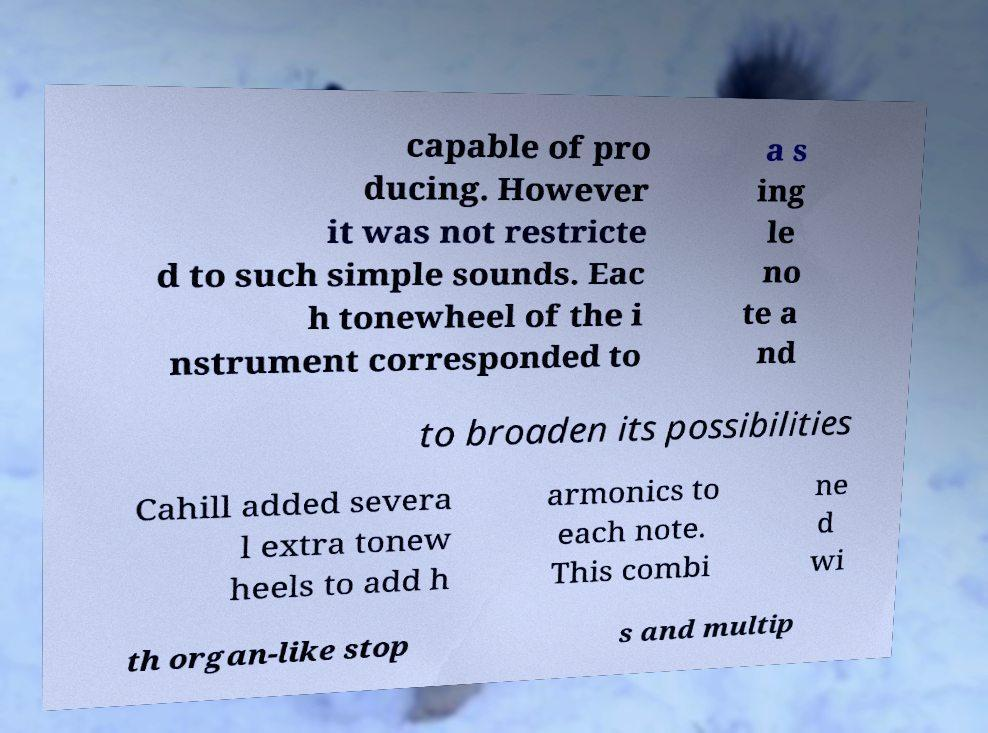For documentation purposes, I need the text within this image transcribed. Could you provide that? capable of pro ducing. However it was not restricte d to such simple sounds. Eac h tonewheel of the i nstrument corresponded to a s ing le no te a nd to broaden its possibilities Cahill added severa l extra tonew heels to add h armonics to each note. This combi ne d wi th organ-like stop s and multip 